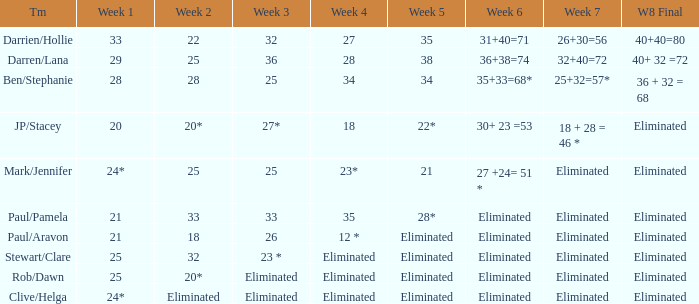Name the team for week 1 of 33 Darrien/Hollie. 